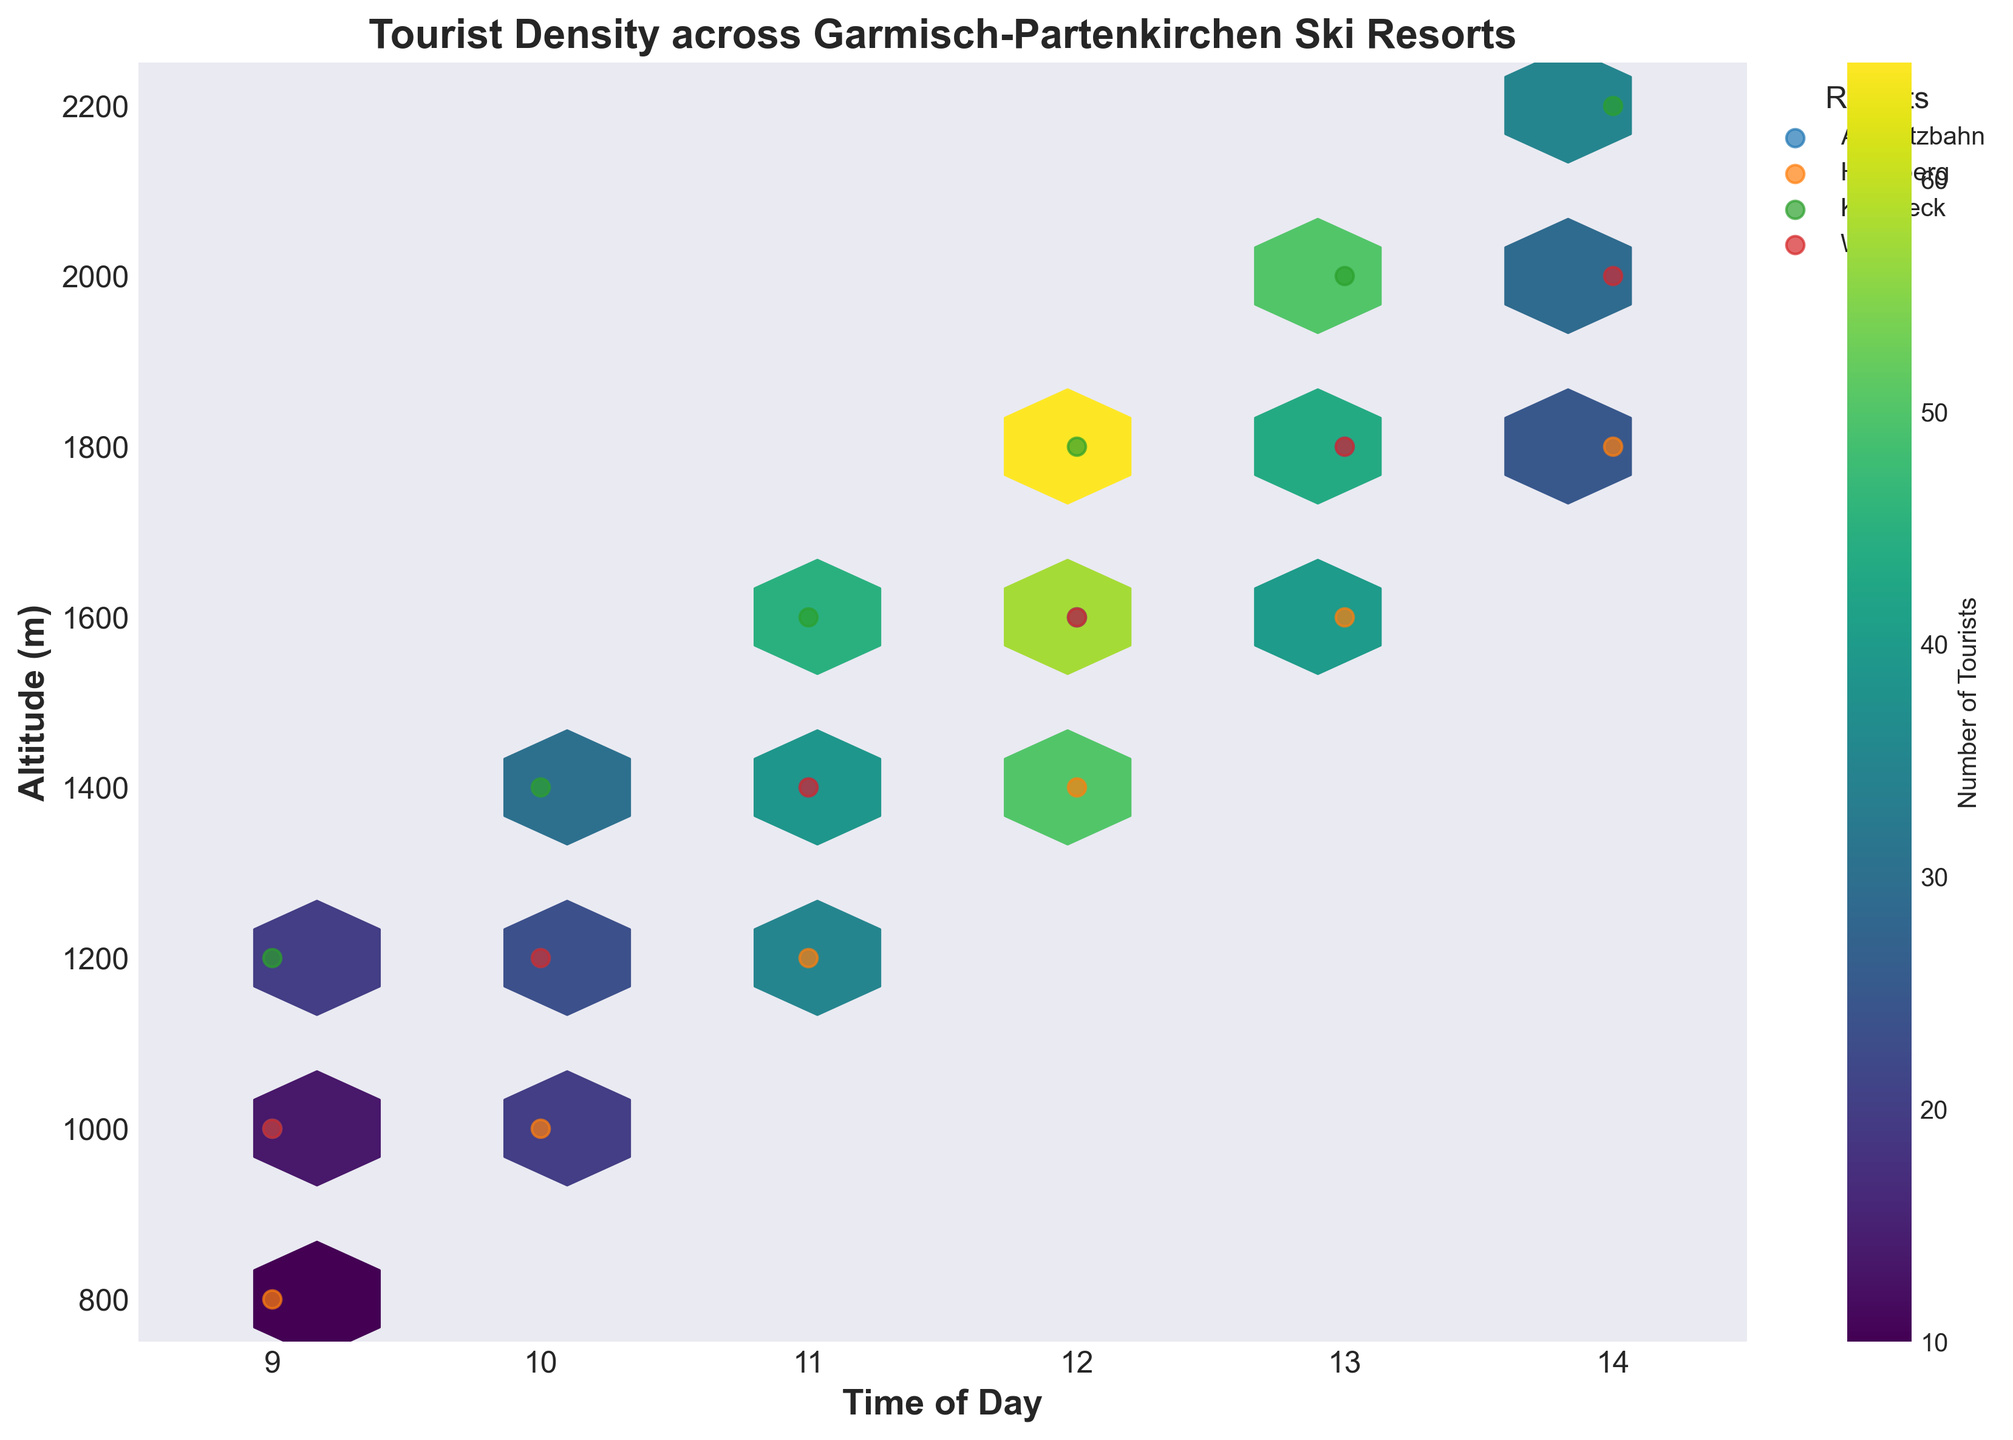What's the title of the hexbin plot? The title of the hexbin plot is located at the top of the figure, which describes the content of the plot. It reads "Tourist Density across Garmisch-Partenkirchen Ski Resorts".
Answer: Tourist Density across Garmisch-Partenkirchen Ski Resorts What are the labels of the X and Y axes? The labels of the X and Y axes describe what each axis represents. The X-axis is labeled "Time of Day" and the Y-axis is labeled "Altitude (m)".
Answer: Time of Day, Altitude (m) How many different ski resorts are represented in the plot? To determine the number of ski resorts, we look for the different labels in the plot’s legend. Each label represents a different ski resort.
Answer: 4 At what time and altitude is the tourist density highest at the Kreuzeck resort? To find the highest tourist density at the Kreuzeck resort, identify the brightest (most yellow) hexagonal bin corresponding to Kreuzeck's data points in the plot. The peak is at 12 PM and 1800 meters.
Answer: 12 PM, 1800 meters Which resort shows the lowest tourist density in the morning around 9 AM? To find the resort with the lowest tourist density around 9 AM, look at the scatter points around 9 AM on the x-axis and the color saturations of those points. The Hausberg resort has the lowest density at that time.
Answer: Hausberg Between what times of the day is there the highest tourist density at altitude 1600 meters across all resorts? To find this, locate the hexagonal bins at 1600 meters altitude across different times of day and check for the brightest hexbin. The highest density is observed around 12 PM.
Answer: around 12 PM Do higher altitudes generally see more tourists later in the day? By examining the hexbin plot, we observe the concentration of brighter-colored bins (indicating higher densities) shifting towards higher altitudes as the time progresses.
Answer: Yes Which resort shows a declining trend in tourist density after 1 PM? Identify the trend lines of the scatter plots for each resort after 1 PM (13:00). The Alpspitzbahn resort shows a decline in tourist numbers after 1 PM.
Answer: Alpspitzbahn What is the range of altitude covered in this plot? The Y-axis, labeled as "Altitude (m)", shows the range of altitudes. The altitudes range from 750 meters to 2250 meters.
Answer: 750 to 2250 meters What is the general trend of tourist density at Wank resort as time progresses from 9 AM to 2 PM? Observing the scatter points for Wank resort and the color intensity of hexagonal bins, tourist density generally increases until around 12 PM and then decreases after that time.
Answer: Increases till 12 PM, then decreases 